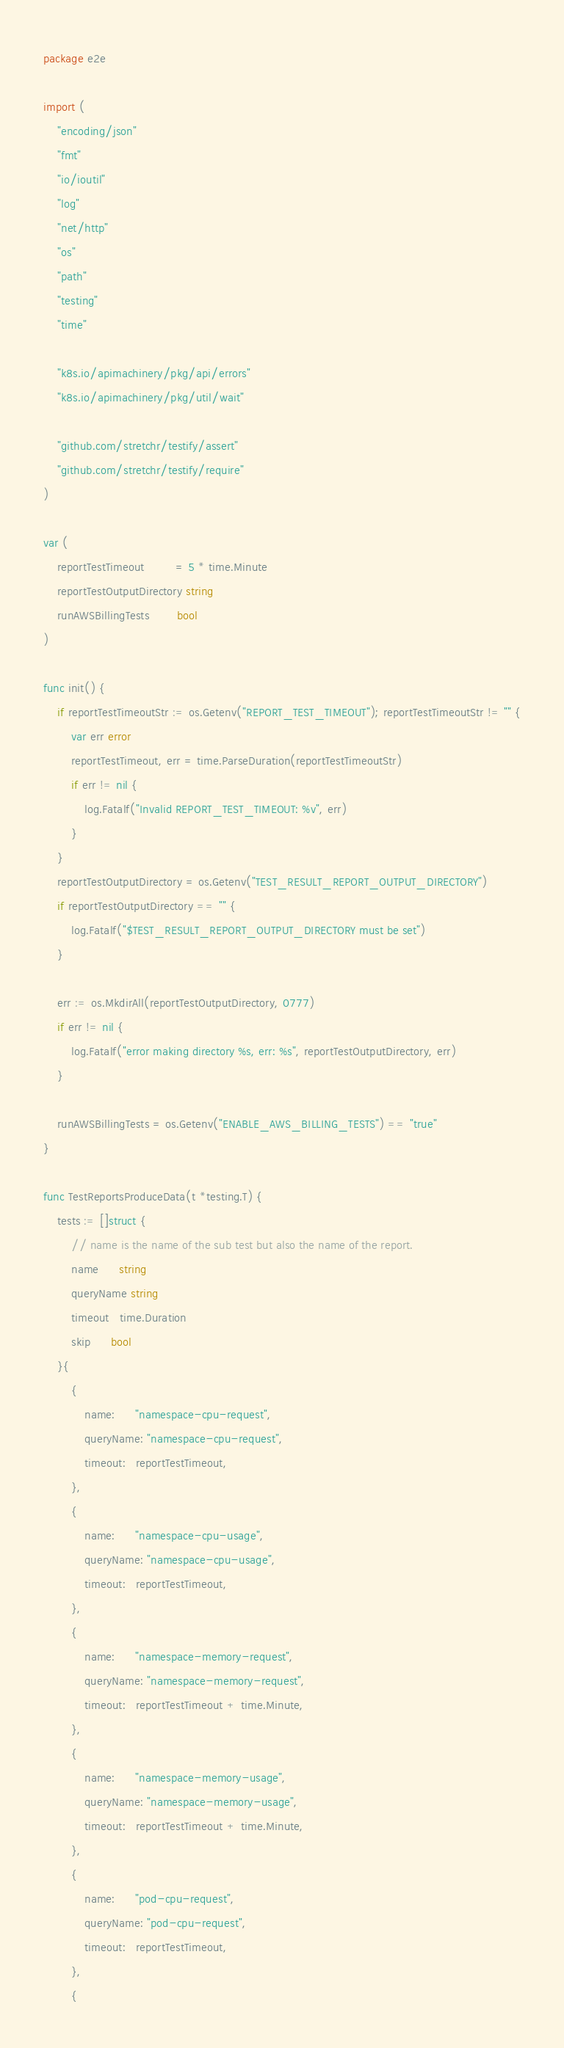<code> <loc_0><loc_0><loc_500><loc_500><_Go_>package e2e

import (
	"encoding/json"
	"fmt"
	"io/ioutil"
	"log"
	"net/http"
	"os"
	"path"
	"testing"
	"time"

	"k8s.io/apimachinery/pkg/api/errors"
	"k8s.io/apimachinery/pkg/util/wait"

	"github.com/stretchr/testify/assert"
	"github.com/stretchr/testify/require"
)

var (
	reportTestTimeout         = 5 * time.Minute
	reportTestOutputDirectory string
	runAWSBillingTests        bool
)

func init() {
	if reportTestTimeoutStr := os.Getenv("REPORT_TEST_TIMEOUT"); reportTestTimeoutStr != "" {
		var err error
		reportTestTimeout, err = time.ParseDuration(reportTestTimeoutStr)
		if err != nil {
			log.Fatalf("Invalid REPORT_TEST_TIMEOUT: %v", err)
		}
	}
	reportTestOutputDirectory = os.Getenv("TEST_RESULT_REPORT_OUTPUT_DIRECTORY")
	if reportTestOutputDirectory == "" {
		log.Fatalf("$TEST_RESULT_REPORT_OUTPUT_DIRECTORY must be set")
	}

	err := os.MkdirAll(reportTestOutputDirectory, 0777)
	if err != nil {
		log.Fatalf("error making directory %s, err: %s", reportTestOutputDirectory, err)
	}

	runAWSBillingTests = os.Getenv("ENABLE_AWS_BILLING_TESTS") == "true"
}

func TestReportsProduceData(t *testing.T) {
	tests := []struct {
		// name is the name of the sub test but also the name of the report.
		name      string
		queryName string
		timeout   time.Duration
		skip      bool
	}{
		{
			name:      "namespace-cpu-request",
			queryName: "namespace-cpu-request",
			timeout:   reportTestTimeout,
		},
		{
			name:      "namespace-cpu-usage",
			queryName: "namespace-cpu-usage",
			timeout:   reportTestTimeout,
		},
		{
			name:      "namespace-memory-request",
			queryName: "namespace-memory-request",
			timeout:   reportTestTimeout + time.Minute,
		},
		{
			name:      "namespace-memory-usage",
			queryName: "namespace-memory-usage",
			timeout:   reportTestTimeout + time.Minute,
		},
		{
			name:      "pod-cpu-request",
			queryName: "pod-cpu-request",
			timeout:   reportTestTimeout,
		},
		{</code> 